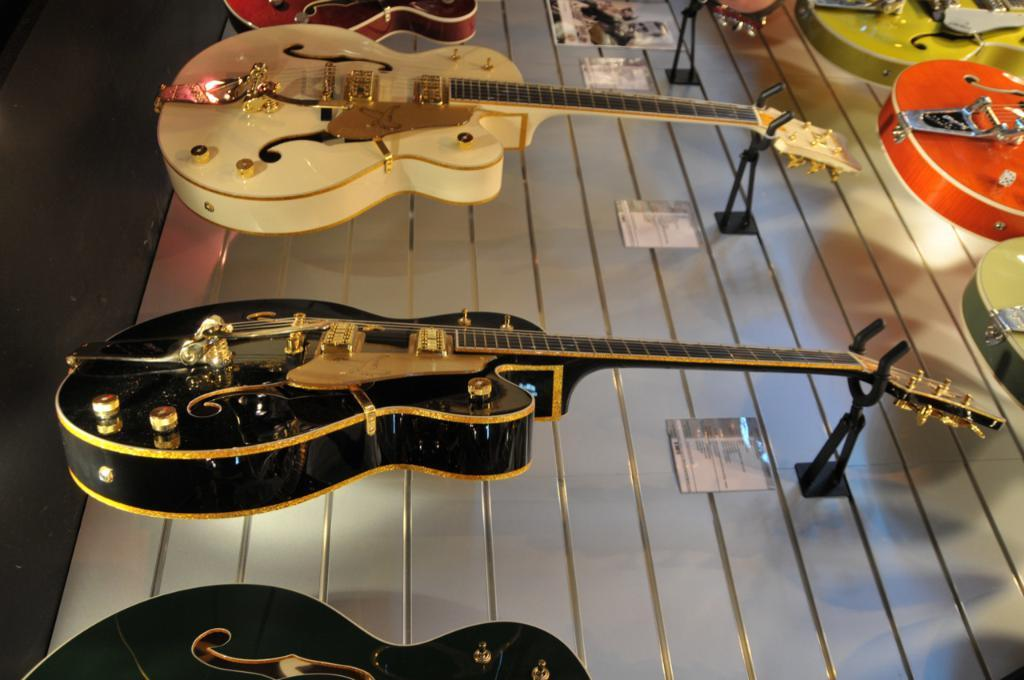What type of musical instruments are in the image? There are guitars in the image. How many guitars can be seen in the image? There are five guitars in the image. What colors are the guitars? The guitars have different colors: green, orange, black, red, and white. What type of stove is visible in the image? There is no stove present in the image; it features guitars of different colors. How many friends are shown playing the guitars in the image? There are no people visible in the image, only the guitars themselves. 